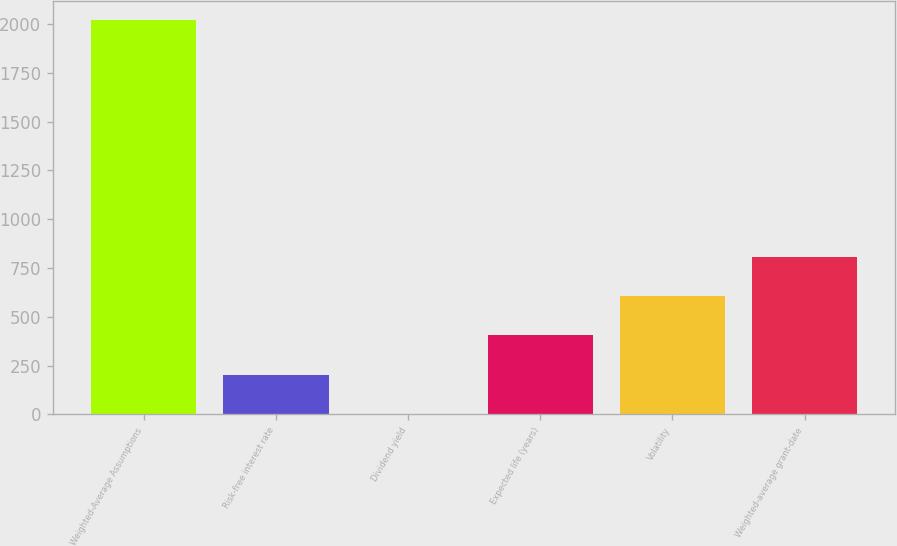Convert chart to OTSL. <chart><loc_0><loc_0><loc_500><loc_500><bar_chart><fcel>Weighted-Average Assumptions<fcel>Risk-free interest rate<fcel>Dividend yield<fcel>Expected life (years)<fcel>Volatility<fcel>Weighted-average grant-date<nl><fcel>2018<fcel>203.87<fcel>2.3<fcel>405.44<fcel>607.01<fcel>808.58<nl></chart> 